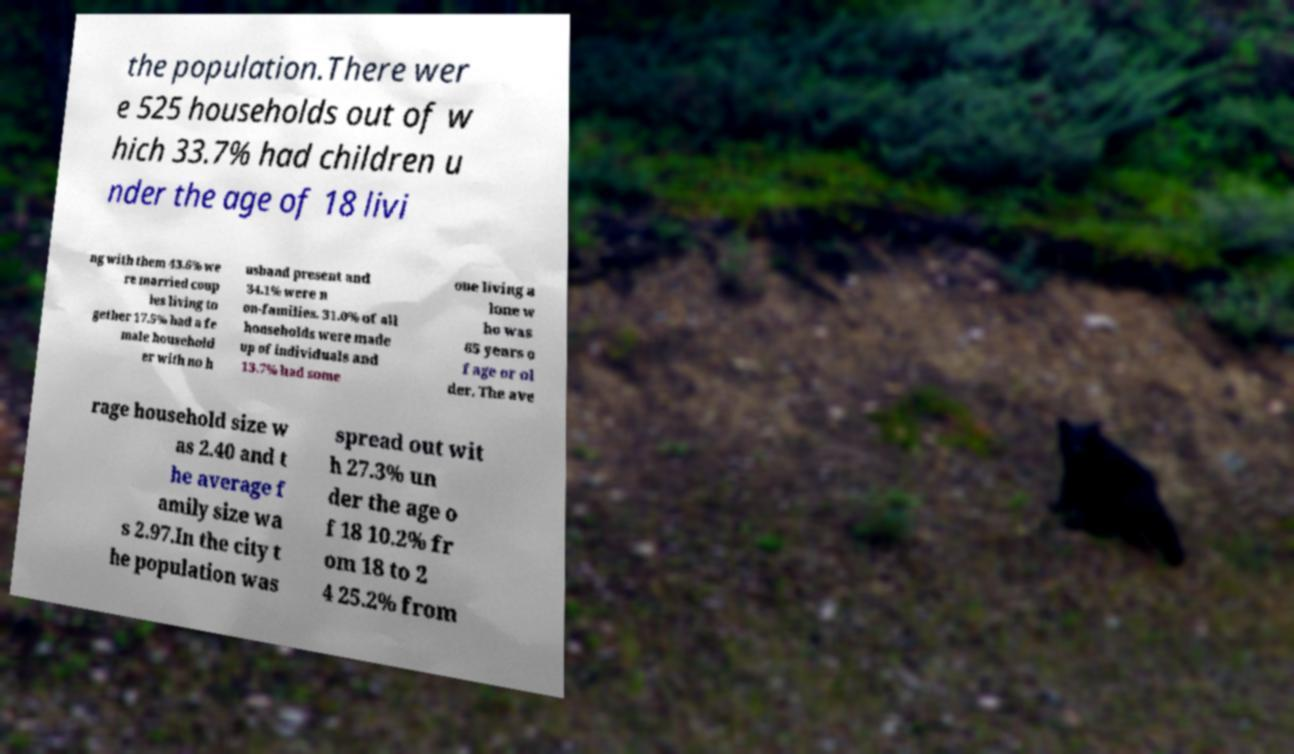Can you read and provide the text displayed in the image?This photo seems to have some interesting text. Can you extract and type it out for me? the population.There wer e 525 households out of w hich 33.7% had children u nder the age of 18 livi ng with them 43.6% we re married coup les living to gether 17.5% had a fe male household er with no h usband present and 34.1% were n on-families. 31.0% of all households were made up of individuals and 13.7% had some one living a lone w ho was 65 years o f age or ol der. The ave rage household size w as 2.40 and t he average f amily size wa s 2.97.In the city t he population was spread out wit h 27.3% un der the age o f 18 10.2% fr om 18 to 2 4 25.2% from 